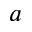Convert formula to latex. <formula><loc_0><loc_0><loc_500><loc_500>a</formula> 